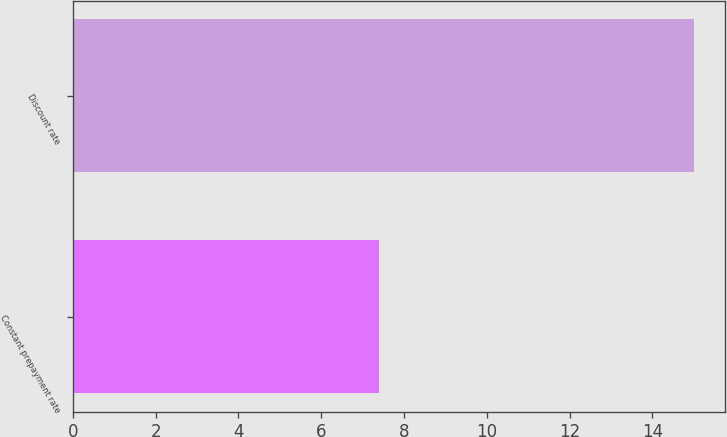<chart> <loc_0><loc_0><loc_500><loc_500><bar_chart><fcel>Constant prepayment rate<fcel>Discount rate<nl><fcel>7.4<fcel>15<nl></chart> 